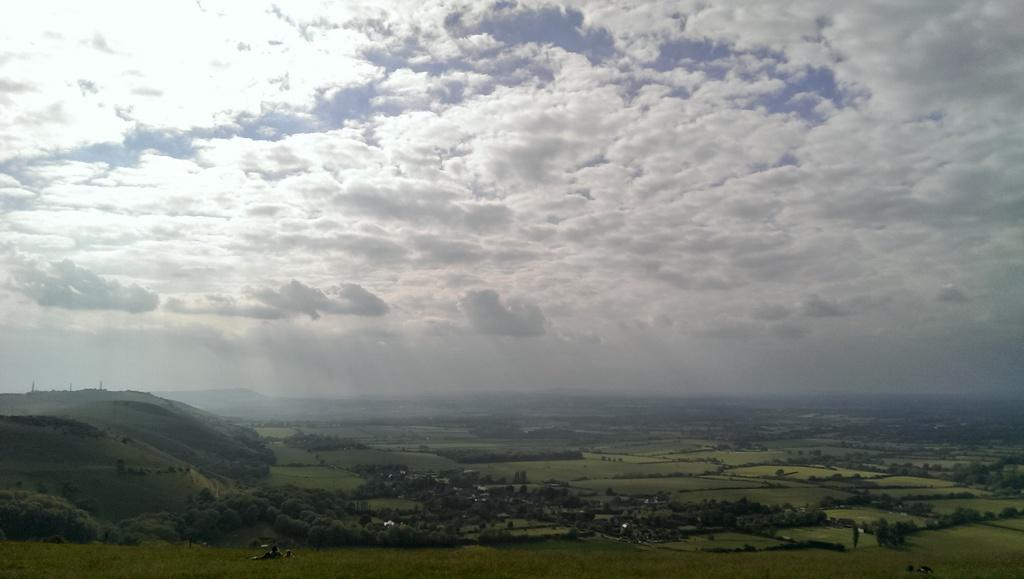What type of natural landscape is depicted in the image? There is a group of trees and mountains in the image. What is the condition of the sky in the image? The sky is cloudy in the image. How many women are wearing a suit while standing next to the trees in the image? There are no women or suits present in the image; it features a group of trees and mountains with a cloudy sky. 